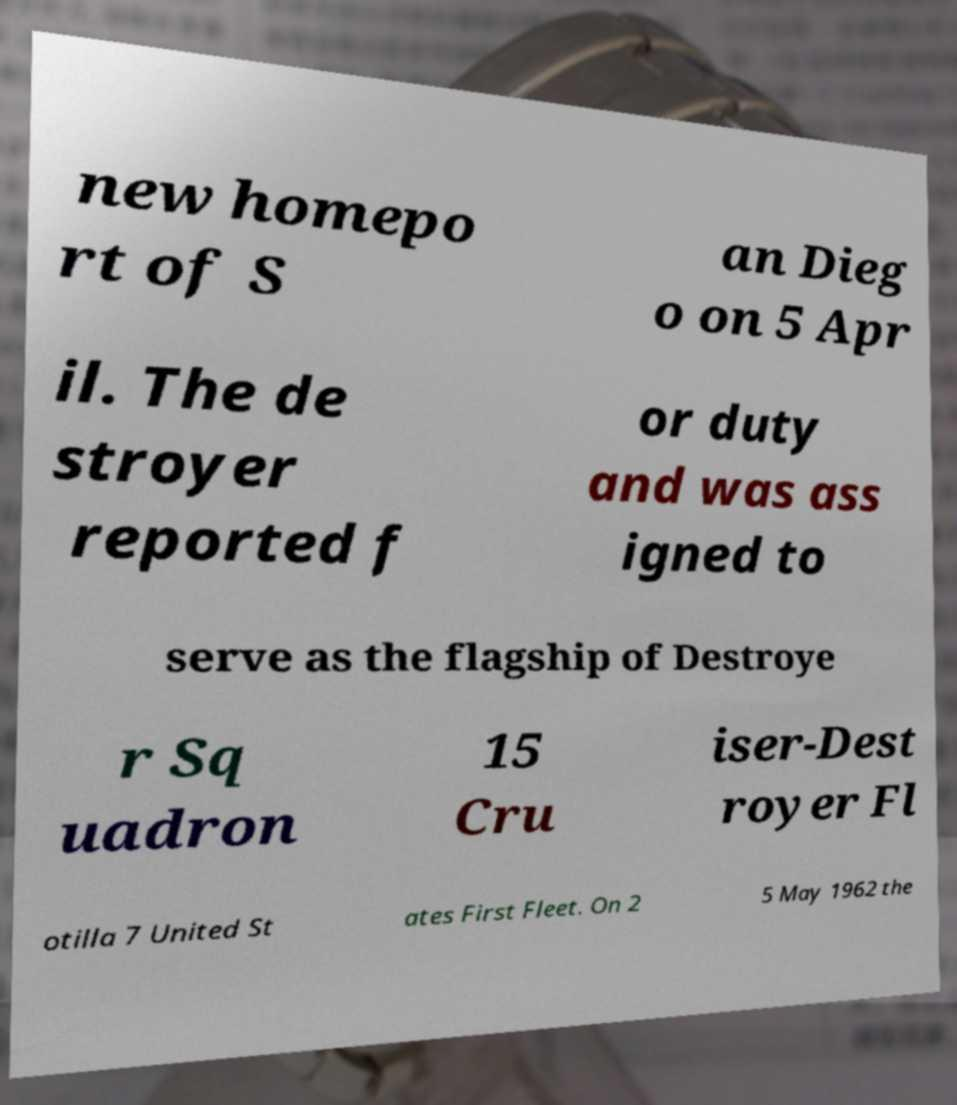Please read and relay the text visible in this image. What does it say? new homepo rt of S an Dieg o on 5 Apr il. The de stroyer reported f or duty and was ass igned to serve as the flagship of Destroye r Sq uadron 15 Cru iser-Dest royer Fl otilla 7 United St ates First Fleet. On 2 5 May 1962 the 